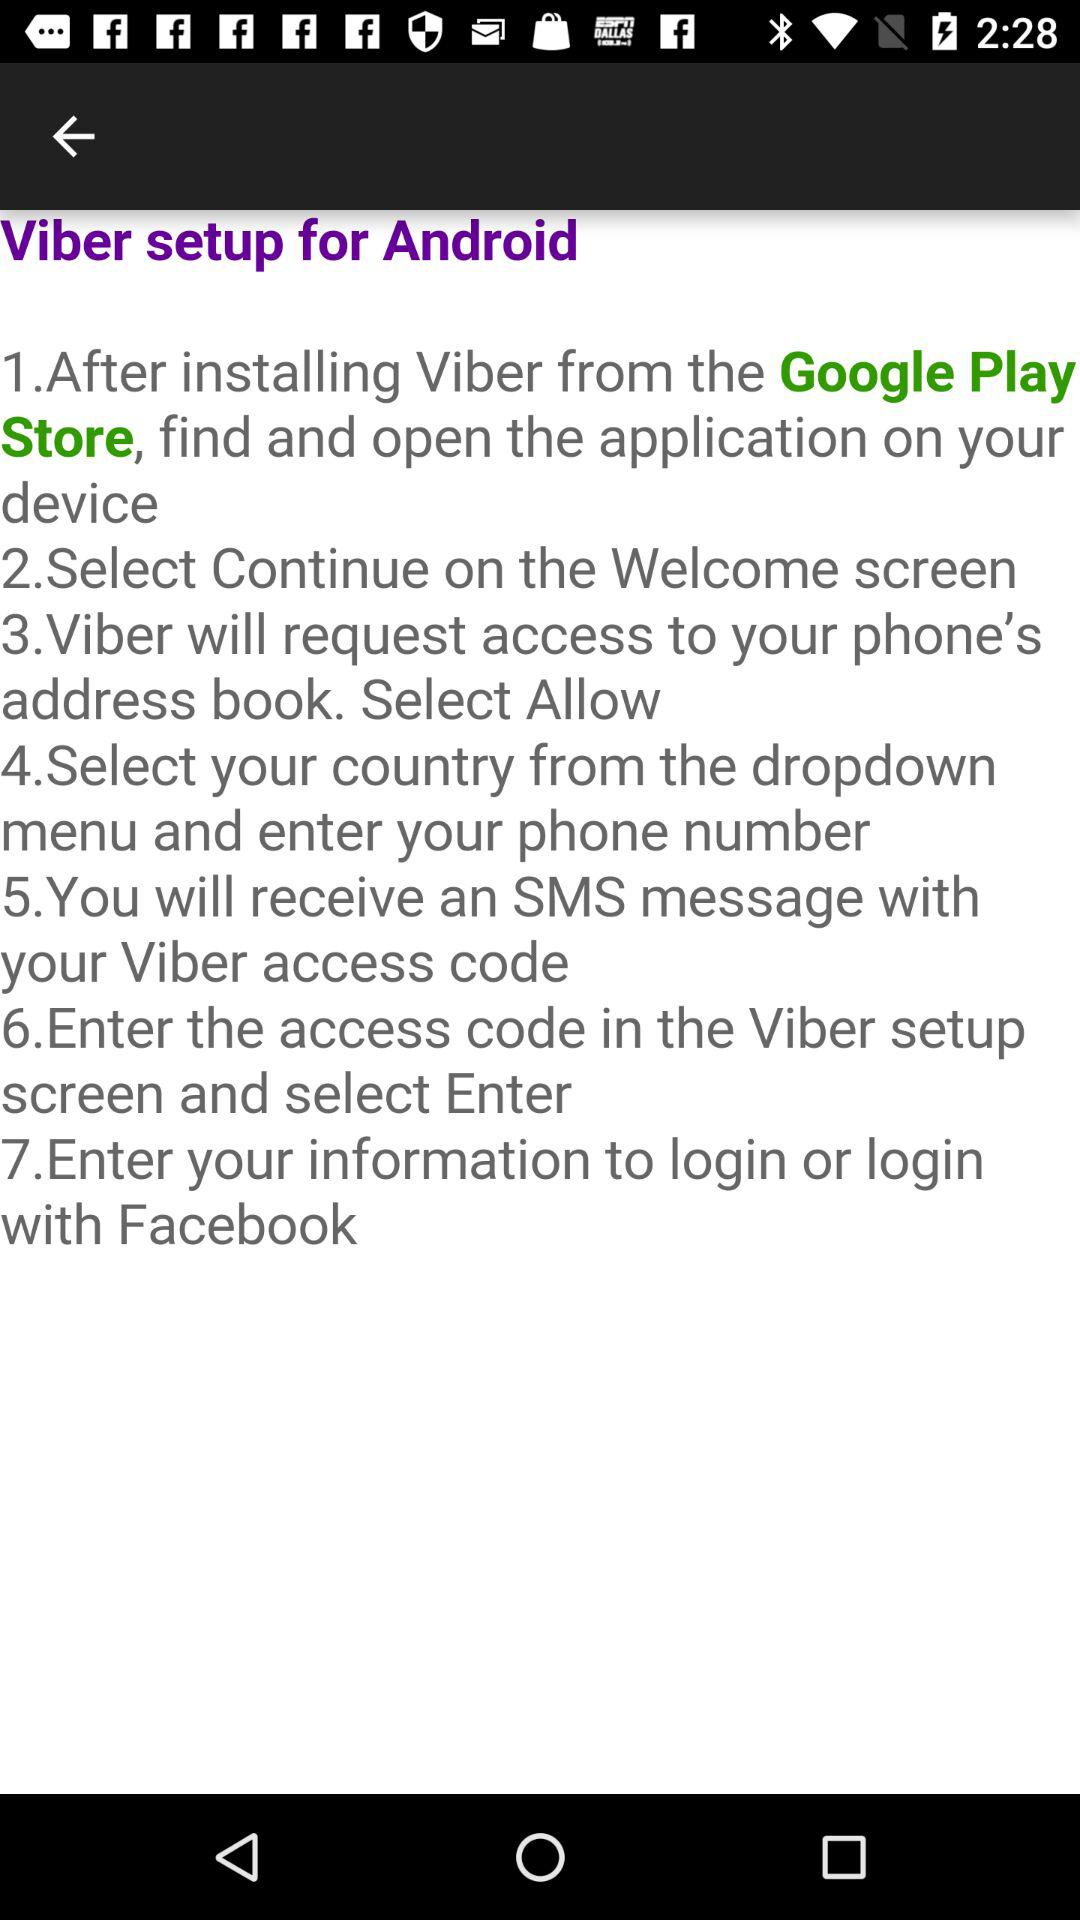What is the name of the application? The name of the application is "Viber". 